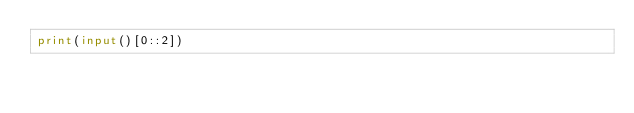<code> <loc_0><loc_0><loc_500><loc_500><_Python_>print(input()[0::2])</code> 